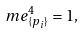Convert formula to latex. <formula><loc_0><loc_0><loc_500><loc_500>\ m e _ { \{ p _ { i } \} } ^ { 4 } = 1 ,</formula> 